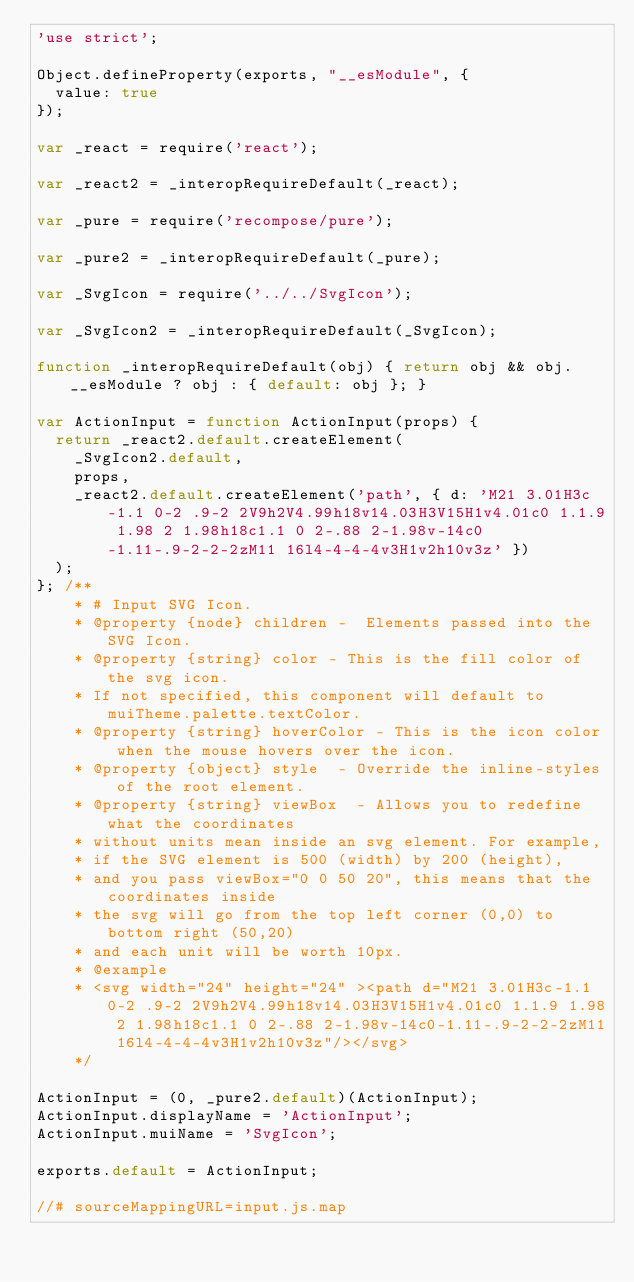<code> <loc_0><loc_0><loc_500><loc_500><_JavaScript_>'use strict';

Object.defineProperty(exports, "__esModule", {
  value: true
});

var _react = require('react');

var _react2 = _interopRequireDefault(_react);

var _pure = require('recompose/pure');

var _pure2 = _interopRequireDefault(_pure);

var _SvgIcon = require('../../SvgIcon');

var _SvgIcon2 = _interopRequireDefault(_SvgIcon);

function _interopRequireDefault(obj) { return obj && obj.__esModule ? obj : { default: obj }; }

var ActionInput = function ActionInput(props) {
  return _react2.default.createElement(
    _SvgIcon2.default,
    props,
    _react2.default.createElement('path', { d: 'M21 3.01H3c-1.1 0-2 .9-2 2V9h2V4.99h18v14.03H3V15H1v4.01c0 1.1.9 1.98 2 1.98h18c1.1 0 2-.88 2-1.98v-14c0-1.11-.9-2-2-2zM11 16l4-4-4-4v3H1v2h10v3z' })
  );
}; /** 
    * # Input SVG Icon. 
    * @property {node} children -  Elements passed into the SVG Icon.
    * @property {string} color - This is the fill color of the svg icon.
    * If not specified, this component will default to muiTheme.palette.textColor.
    * @property {string} hoverColor - This is the icon color when the mouse hovers over the icon.
    * @property {object} style	- Override the inline-styles of the root element.
    * @property {string} viewBox  - Allows you to redefine what the coordinates
    * without units mean inside an svg element. For example,
    * if the SVG element is 500 (width) by 200 (height),
    * and you pass viewBox="0 0 50 20", this means that the coordinates inside
    * the svg will go from the top left corner (0,0) to bottom right (50,20)
    * and each unit will be worth 10px. 
    * @example 
    * <svg width="24" height="24" ><path d="M21 3.01H3c-1.1 0-2 .9-2 2V9h2V4.99h18v14.03H3V15H1v4.01c0 1.1.9 1.98 2 1.98h18c1.1 0 2-.88 2-1.98v-14c0-1.11-.9-2-2-2zM11 16l4-4-4-4v3H1v2h10v3z"/></svg> 
    */

ActionInput = (0, _pure2.default)(ActionInput);
ActionInput.displayName = 'ActionInput';
ActionInput.muiName = 'SvgIcon';

exports.default = ActionInput;

//# sourceMappingURL=input.js.map</code> 